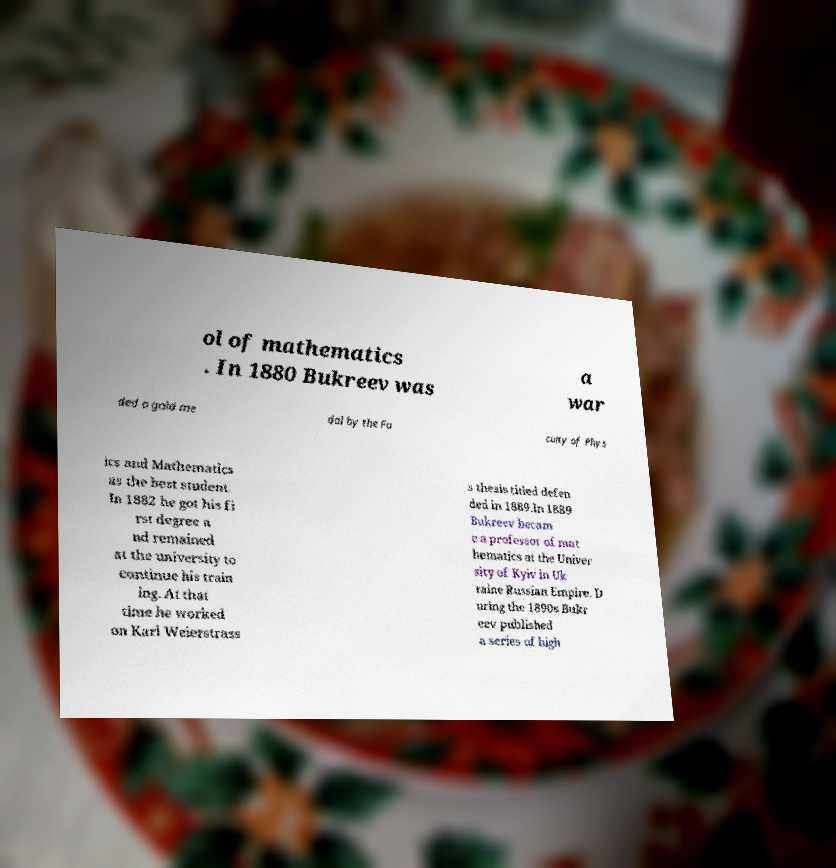Can you accurately transcribe the text from the provided image for me? ol of mathematics . In 1880 Bukreev was a war ded a gold me dal by the Fa culty of Phys ics and Mathematics as the best student. In 1882 he got his fi rst degree a nd remained at the university to continue his train ing. At that time he worked on Karl Weierstrass s thesis titled defen ded in 1889.In 1889 Bukreev becam e a professor of mat hematics at the Univer sity of Kyiv in Uk raine Russian Empire. D uring the 1890s Bukr eev published a series of high 